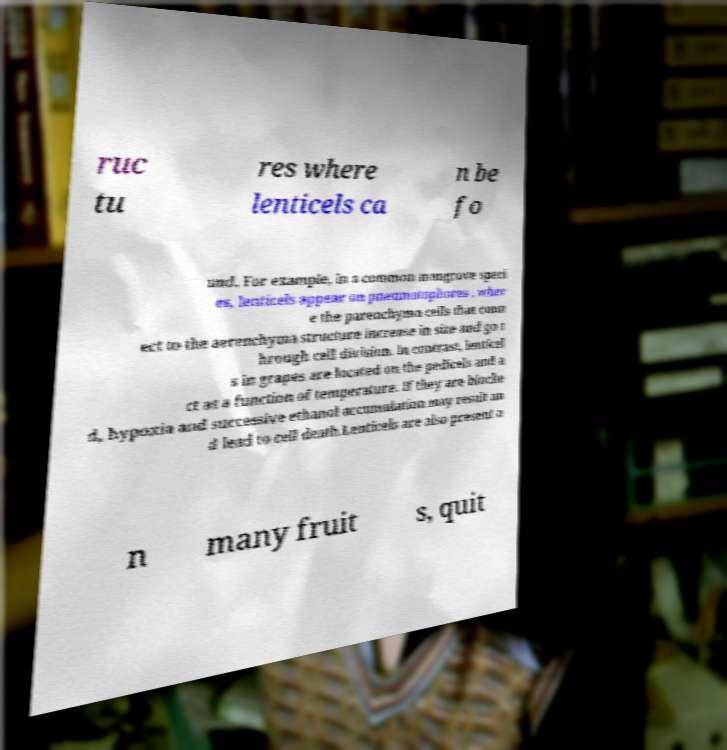Could you assist in decoding the text presented in this image and type it out clearly? ruc tu res where lenticels ca n be fo und. For example, in a common mangrove speci es, lenticels appear on pneumatophores , wher e the parenchyma cells that conn ect to the aerenchyma structure increase in size and go t hrough cell division. In contrast, lenticel s in grapes are located on the pedicels and a ct as a function of temperature. If they are blocke d, hypoxia and successive ethanol accumulation may result an d lead to cell death.Lenticels are also present o n many fruit s, quit 